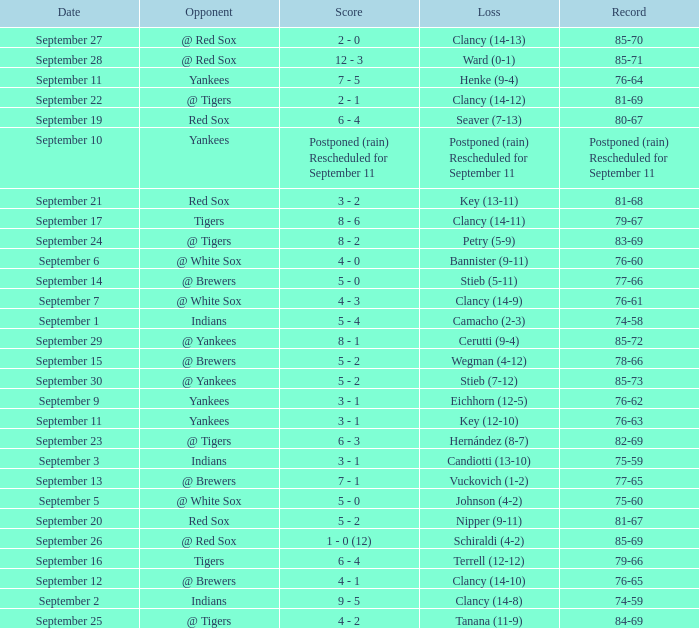What is the specific date of the game when they had an 84-69 record? September 25. 